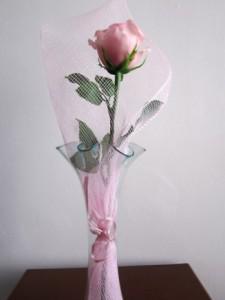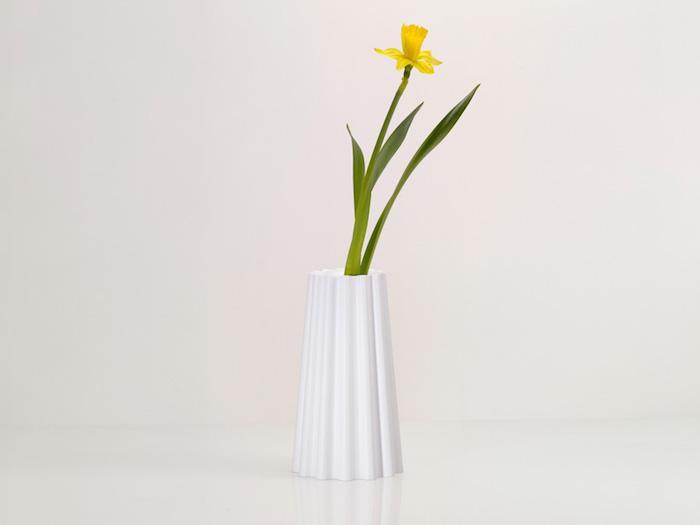The first image is the image on the left, the second image is the image on the right. Considering the images on both sides, is "The flower in the white vase on the right is yellow." valid? Answer yes or no. Yes. 